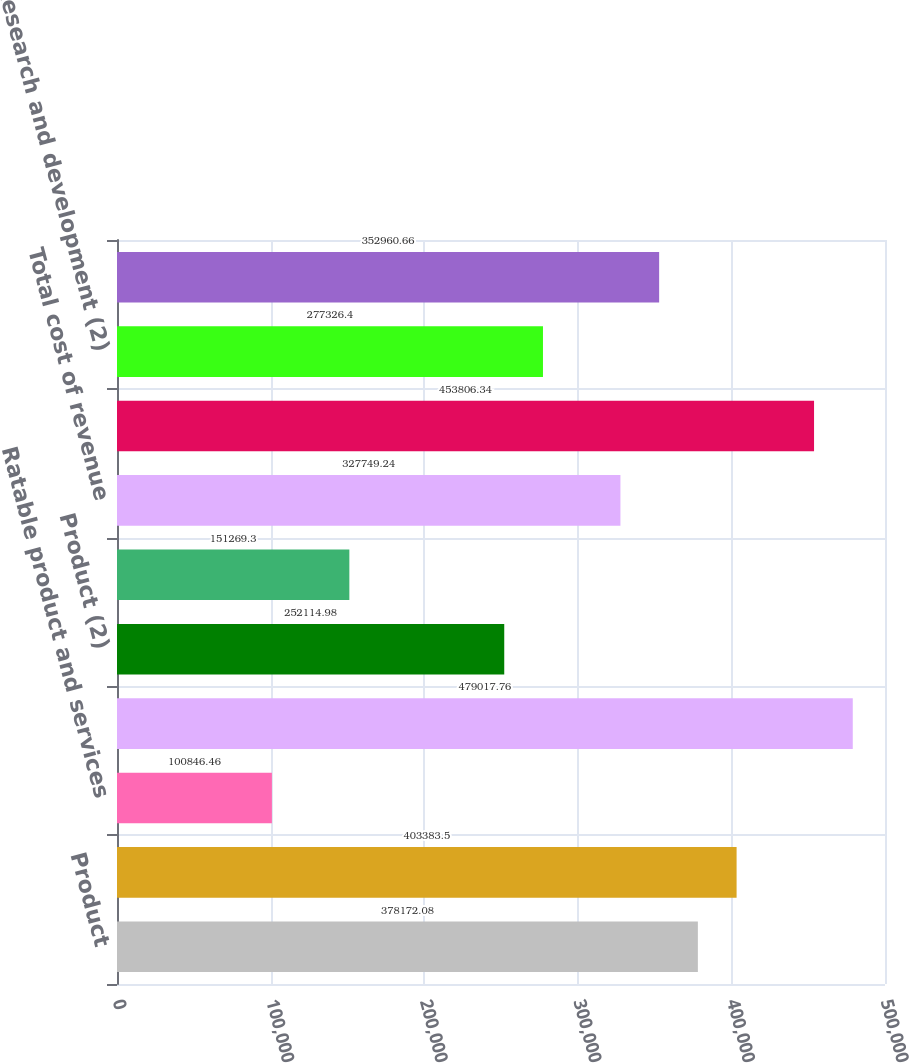Convert chart to OTSL. <chart><loc_0><loc_0><loc_500><loc_500><bar_chart><fcel>Product<fcel>Services<fcel>Ratable product and services<fcel>Total revenue<fcel>Product (2)<fcel>Services (2)<fcel>Total cost of revenue<fcel>Total gross profit<fcel>Research and development (2)<fcel>Sales and marketing (2)<nl><fcel>378172<fcel>403384<fcel>100846<fcel>479018<fcel>252115<fcel>151269<fcel>327749<fcel>453806<fcel>277326<fcel>352961<nl></chart> 